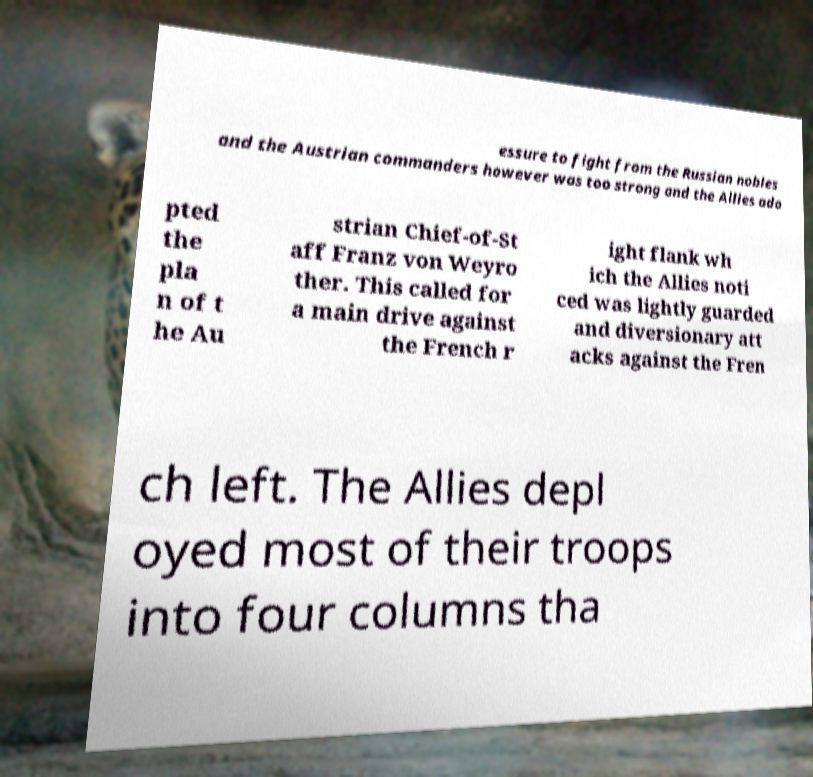For documentation purposes, I need the text within this image transcribed. Could you provide that? essure to fight from the Russian nobles and the Austrian commanders however was too strong and the Allies ado pted the pla n of t he Au strian Chief-of-St aff Franz von Weyro ther. This called for a main drive against the French r ight flank wh ich the Allies noti ced was lightly guarded and diversionary att acks against the Fren ch left. The Allies depl oyed most of their troops into four columns tha 